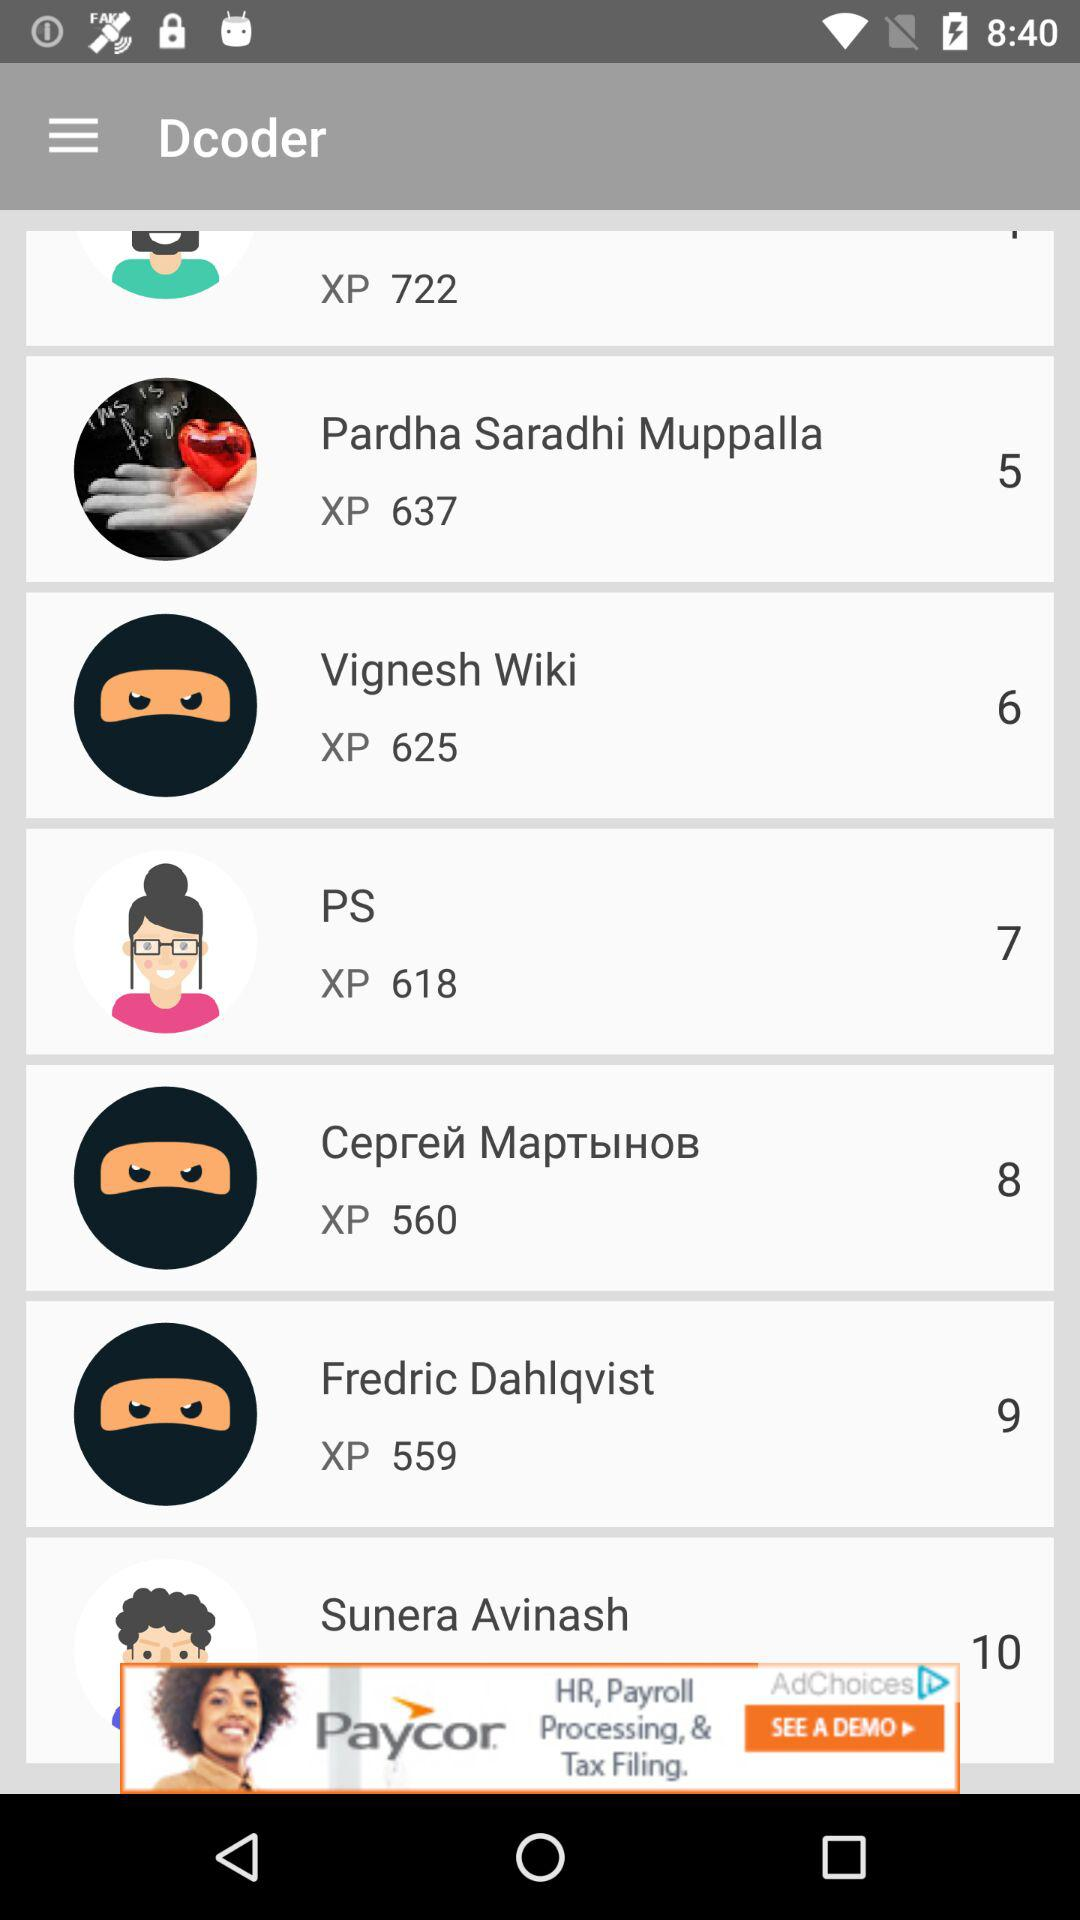Who got 5 points? Pardha Saradhi Muppala got 5 points. 